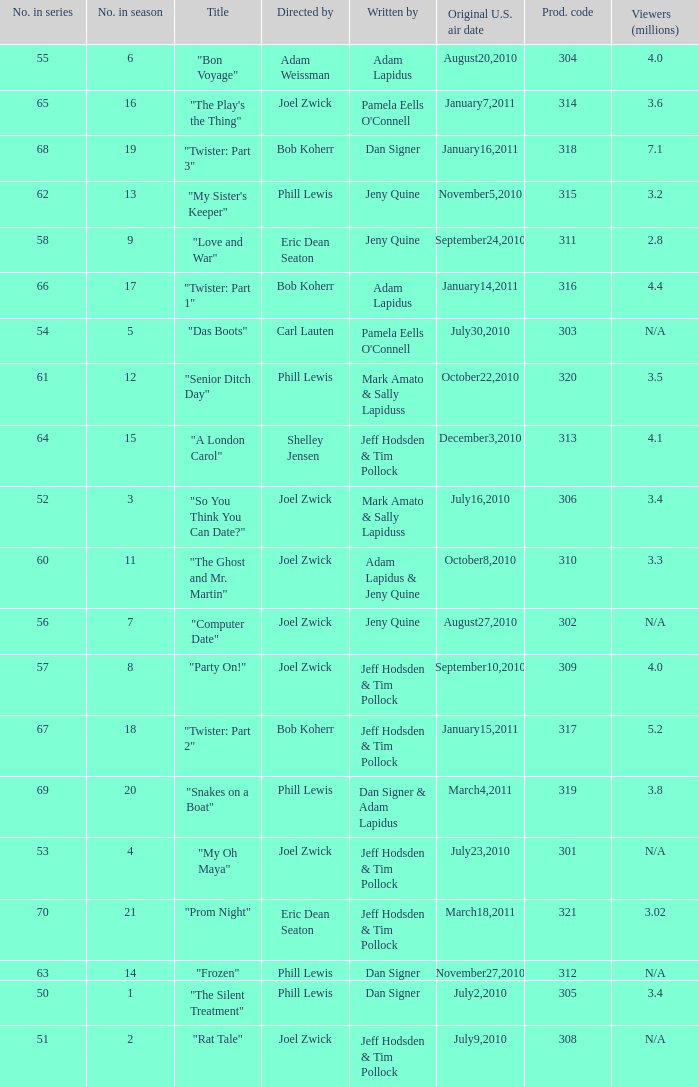How many million viewers watched episode 6? 4.0. 